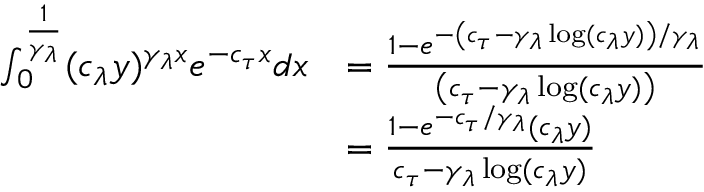Convert formula to latex. <formula><loc_0><loc_0><loc_500><loc_500>\begin{array} { r l } { \int _ { 0 } ^ { \frac { 1 } { \gamma _ { \lambda } } } ( c _ { \lambda } y ) ^ { \gamma _ { \lambda } x } e ^ { - c _ { \tau } x } d x } & { = \frac { 1 - e ^ { - \left ( c _ { \tau } - \gamma _ { \lambda } \log ( c _ { \lambda } y ) \right ) / \gamma _ { \lambda } } } { \left ( c _ { \tau } - \gamma _ { \lambda } \log ( c _ { \lambda } y ) \right ) } } \\ & { = \frac { 1 - e ^ { - c _ { \tau } / \gamma _ { \lambda } } ( c _ { \lambda } y ) } { c _ { \tau } - \gamma _ { \lambda } \log ( c _ { \lambda } y ) } } \end{array}</formula> 